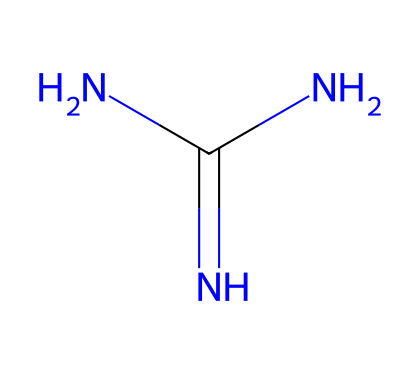What is the IUPAC name of this chemical? The SMILES representation NC(=N)N corresponds to guanidine, which has the IUPAC name 1,1-diaminourea. This name describes the chemical's functional groups and structure.
Answer: guanidine How many nitrogen atoms are in the guanidine structure? Analyzing the SMILES notation, NC(=N)N indicates one nitrogen bonded to carbon and two additional nitrogen atoms linked in the overall structure. Therefore, there are three nitrogen atoms.
Answer: 3 How many hydrogen atoms are bonded to the nitrogen in guanidine? The structure shows one nitrogen atom (attached to a carbon), and the other two nitrogen atoms each have two hydrogen atoms by balancing the valencies. Thus, there are a total of six hydrogen atoms.
Answer: 6 What type of functional group does guanidine predominantly contain? The presence of multiple nitrogen atoms grouped together indicates that guanidine contains an amine functional group, specifically in this case, two primary amine groups.
Answer: amine Is guanidine considered a superbase? Guanidine exhibits high basicity due to its nitrogen structure making it a strong base in chemical reactions, thus classifying it as a superbase.
Answer: Yes 